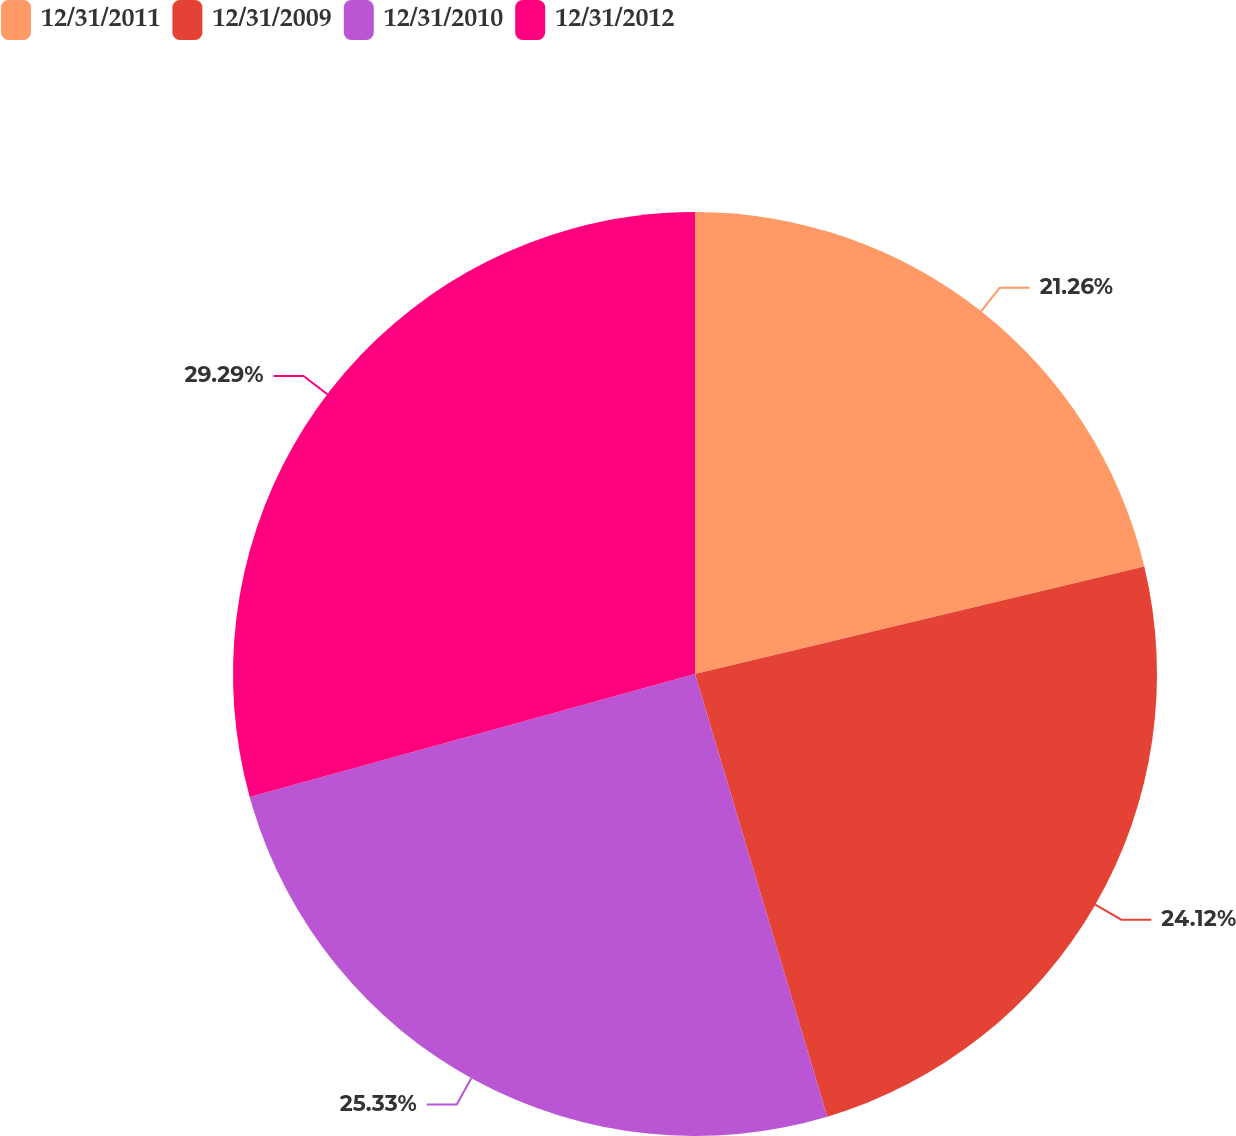Convert chart to OTSL. <chart><loc_0><loc_0><loc_500><loc_500><pie_chart><fcel>12/31/2011<fcel>12/31/2009<fcel>12/31/2010<fcel>12/31/2012<nl><fcel>21.26%<fcel>24.12%<fcel>25.33%<fcel>29.29%<nl></chart> 